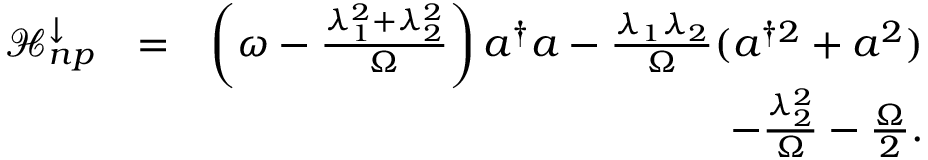<formula> <loc_0><loc_0><loc_500><loc_500>\begin{array} { r l r } { \mathcal { H } _ { n p } ^ { \downarrow } } & { = } & { \left ( \omega - \frac { \lambda _ { 1 } ^ { 2 } + \lambda _ { 2 } ^ { 2 } } { \Omega } \right ) a ^ { \dagger } a - \frac { \lambda _ { 1 } \lambda _ { 2 } } { \Omega } ( a ^ { \dagger 2 } + a ^ { 2 } ) } \\ & { - \frac { \lambda _ { 2 } ^ { 2 } } { \Omega } - \frac { \Omega } { 2 } . } \end{array}</formula> 